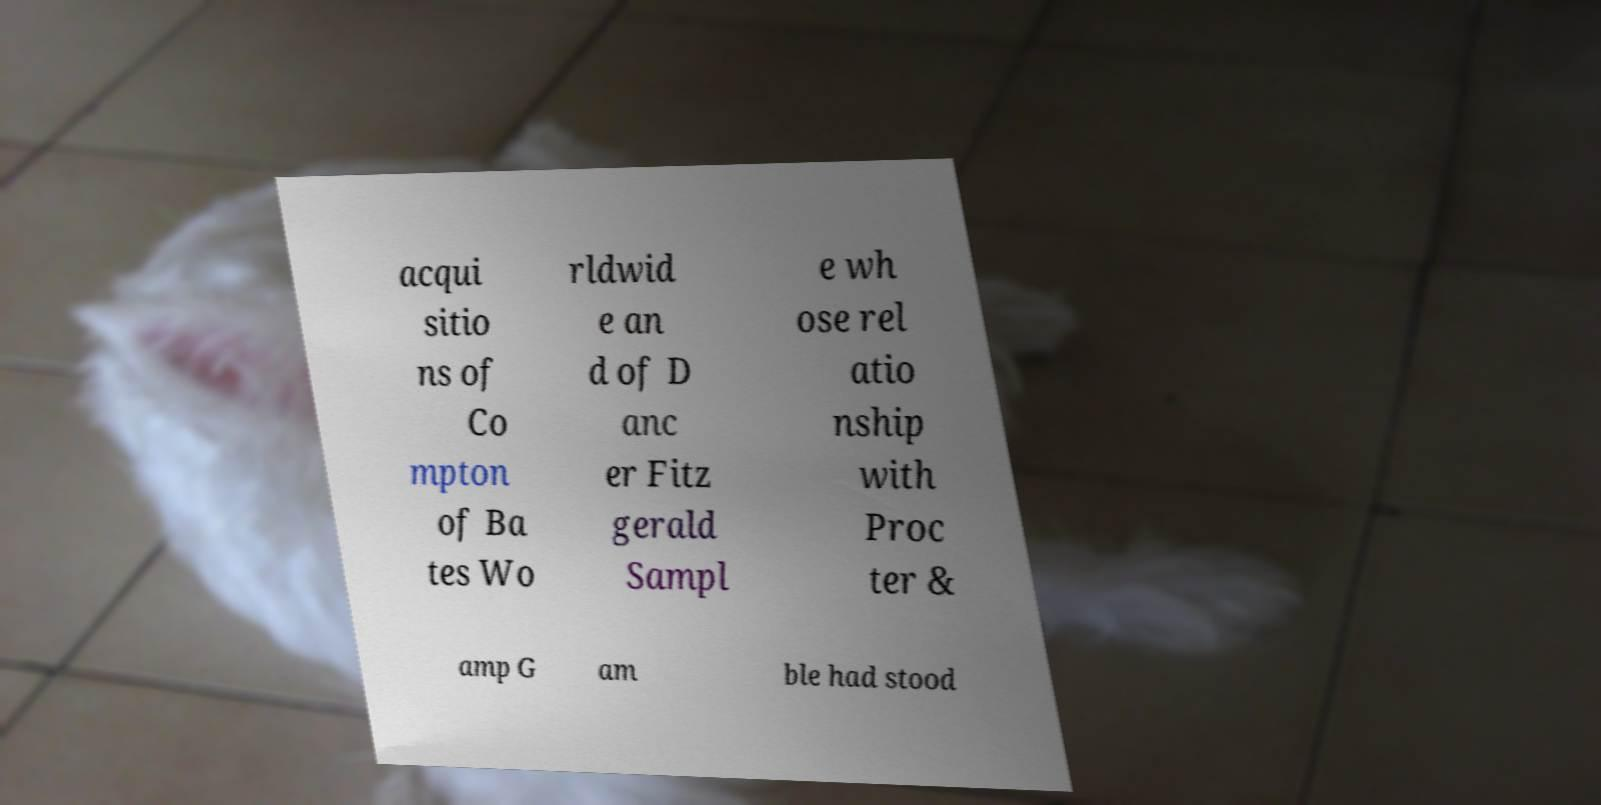Please identify and transcribe the text found in this image. acqui sitio ns of Co mpton of Ba tes Wo rldwid e an d of D anc er Fitz gerald Sampl e wh ose rel atio nship with Proc ter & amp G am ble had stood 